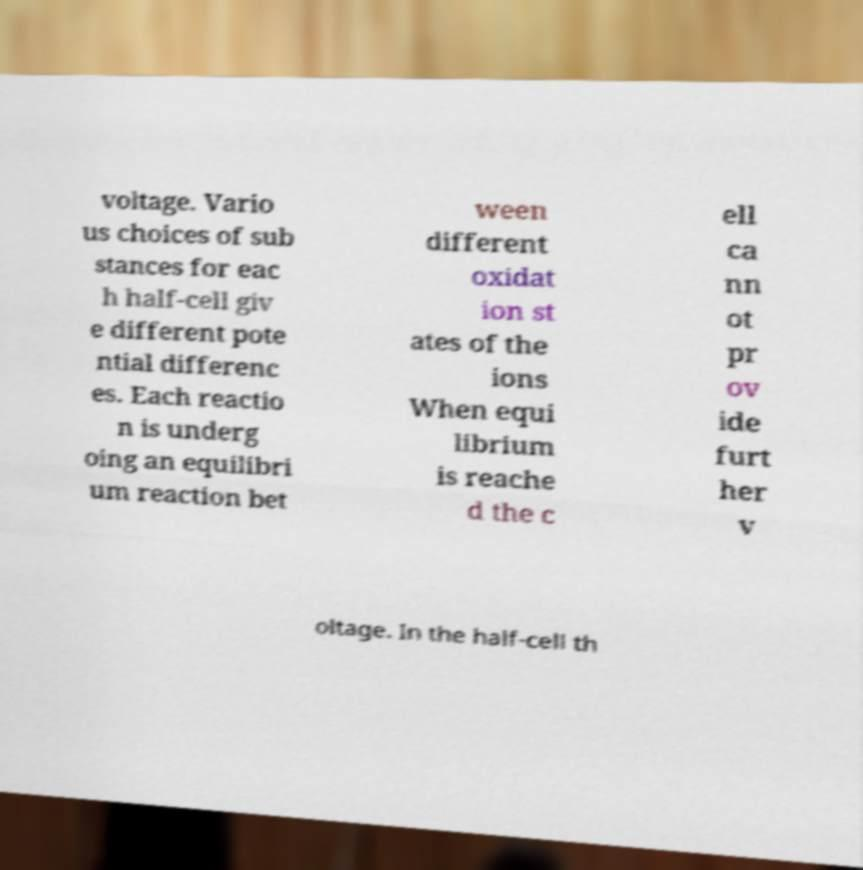Could you assist in decoding the text presented in this image and type it out clearly? voltage. Vario us choices of sub stances for eac h half-cell giv e different pote ntial differenc es. Each reactio n is underg oing an equilibri um reaction bet ween different oxidat ion st ates of the ions When equi librium is reache d the c ell ca nn ot pr ov ide furt her v oltage. In the half-cell th 